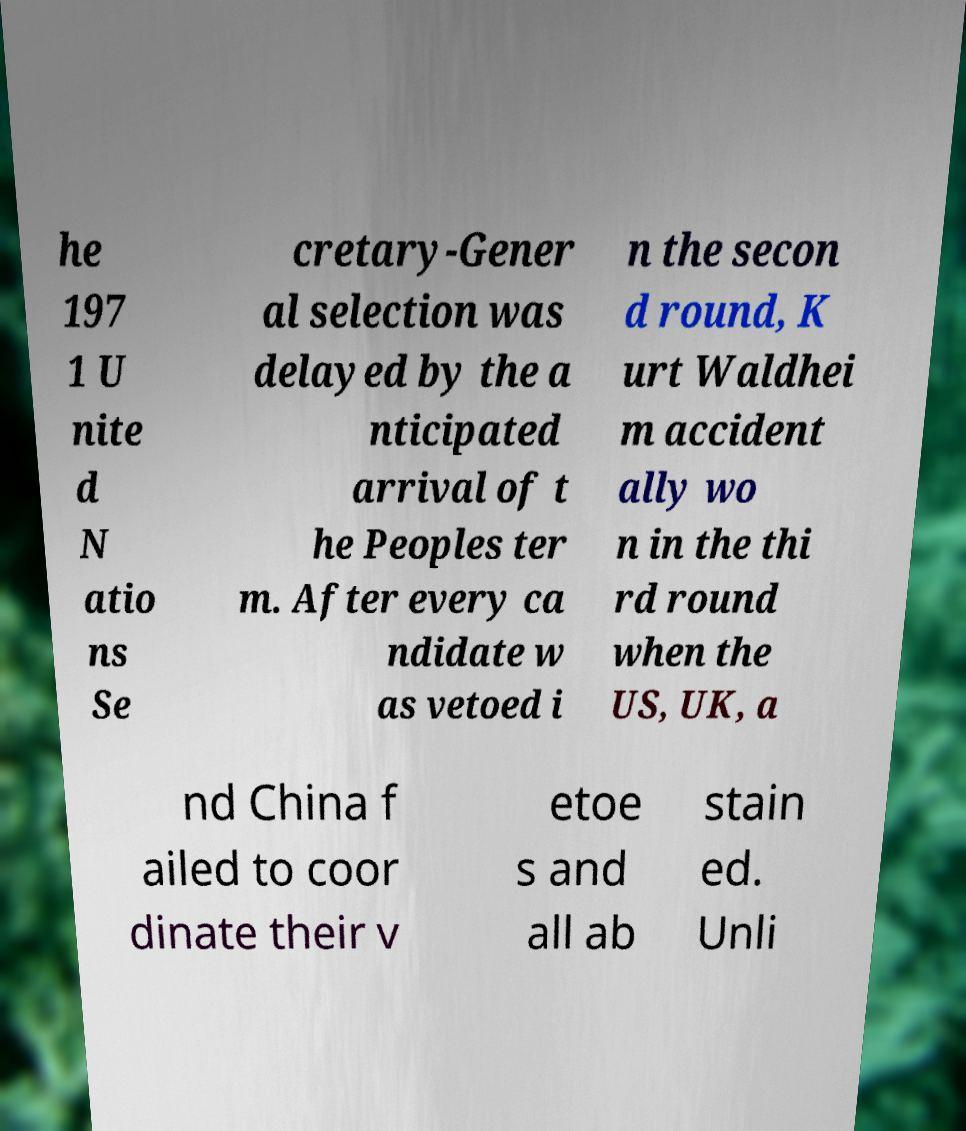For documentation purposes, I need the text within this image transcribed. Could you provide that? he 197 1 U nite d N atio ns Se cretary-Gener al selection was delayed by the a nticipated arrival of t he Peoples ter m. After every ca ndidate w as vetoed i n the secon d round, K urt Waldhei m accident ally wo n in the thi rd round when the US, UK, a nd China f ailed to coor dinate their v etoe s and all ab stain ed. Unli 